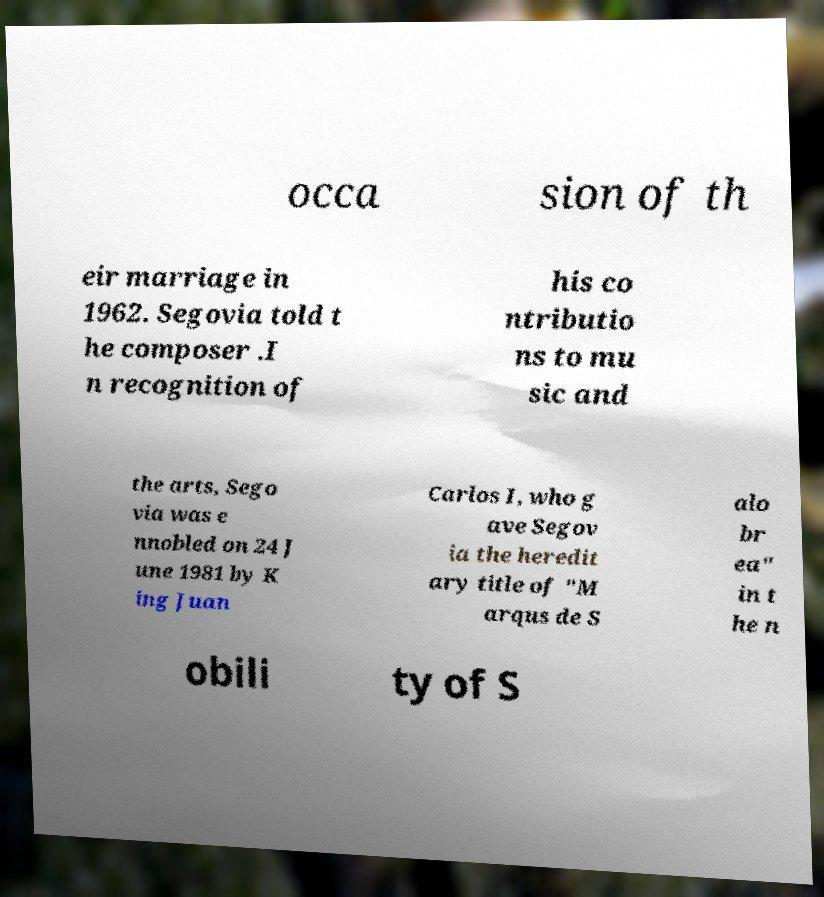What messages or text are displayed in this image? I need them in a readable, typed format. occa sion of th eir marriage in 1962. Segovia told t he composer .I n recognition of his co ntributio ns to mu sic and the arts, Sego via was e nnobled on 24 J une 1981 by K ing Juan Carlos I, who g ave Segov ia the heredit ary title of "M arqus de S alo br ea" in t he n obili ty of S 